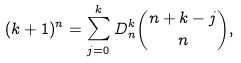<formula> <loc_0><loc_0><loc_500><loc_500>( k + 1 ) ^ { n } = \sum _ { j = 0 } ^ { k } D _ { n } ^ { k } \binom { n + k - j } { n } ,</formula> 